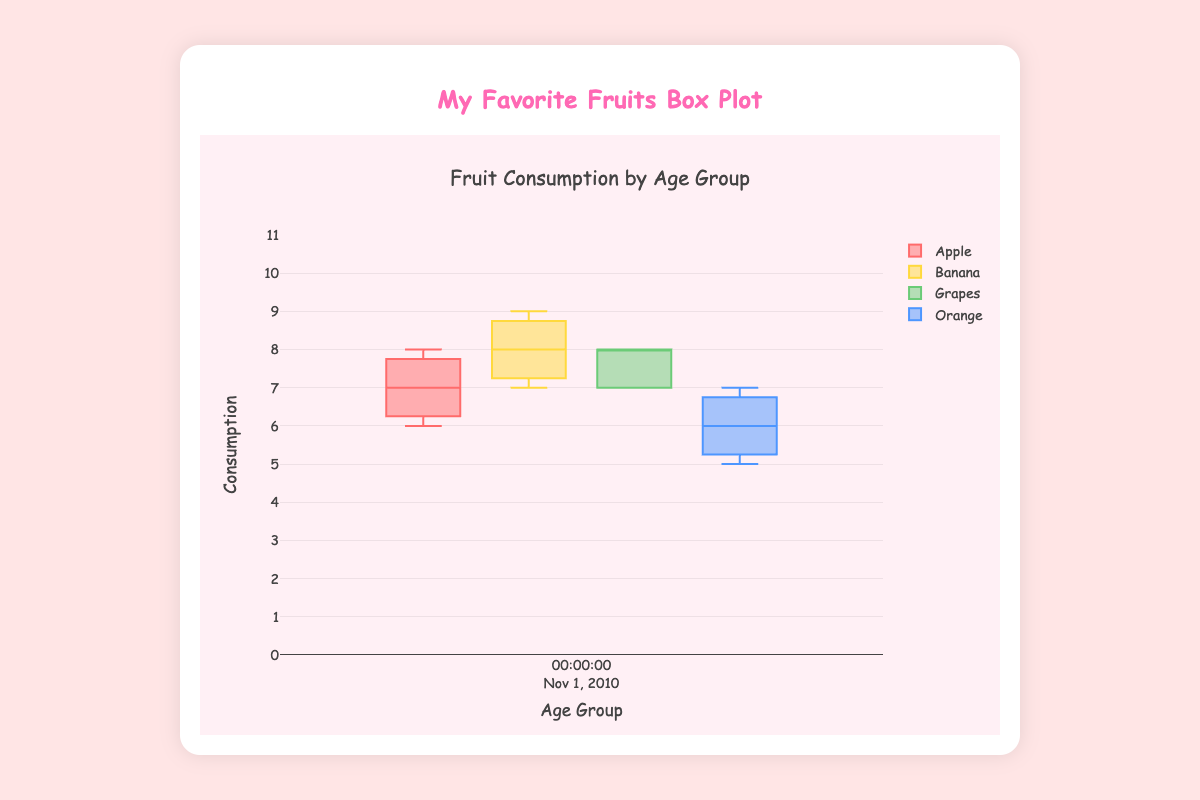What is the title of the chart? Look at the top of the chart where the title is displayed, it says "Fruit Consumption by Age Group".
Answer: Fruit Consumption by Age Group How many fruits are shown in the box plot? There are four different colors/box plots for each age group. Each color represents a different fruit: Apple, Banana, Grapes, and Orange.
Answer: 4 Which age group has the highest median consumption of Bananas? Compare the thick lines inside the boxes for Bananas across all age groups. The 8-9 age group has a higher median line than the others.
Answer: 8-9 What is the range of consumption values shown on the y-axis? The y-axis runs from 0 to 11 as shown by the numbers and ticks on the y-axis.
Answer: 0 to 11 What color represents the Apple consumption in the box plot? Look at the legend or the colors in the box plots. The box plots for Apple are displayed in red.
Answer: Red Which fruit has the lowest maximum consumption value among the 4-5 age group? Compare the top whiskers of all the fruits in the 4-5 age group. The Orange whisker does not go as high as the others.
Answer: Orange How does the median Apple consumption for the 6-7 age group compare to the 8-9 age group? The median is the thick line inside the boxes. For Apple, the 6-7 age group has a higher median than the 8-9 age group.
Answer: The 6-7 age group has a higher median What is the difference in median Grape consumption between the 6-7 and 10-11 age groups? Find the median lines (thick lines) for Grapes in both age groups. The median for 6-7 is 7, and for 10-11 it is also 7, so the difference is 0.
Answer: 0 Which fruit and age group combination shows the largest spread in consumption values? The spread is the distance between the bottom and top whiskers. For Bananas in age group 8-9, the spread is large as the whiskers extend from 8 to 10.
Answer: Banana in 8-9 age group What is the general trend of Banana consumption across the age groups? Observe the position and length of the Banana box plots from 4-5 to 10-11. The median and the spread tend to be consistently high in each age group.
Answer: Consistently high 